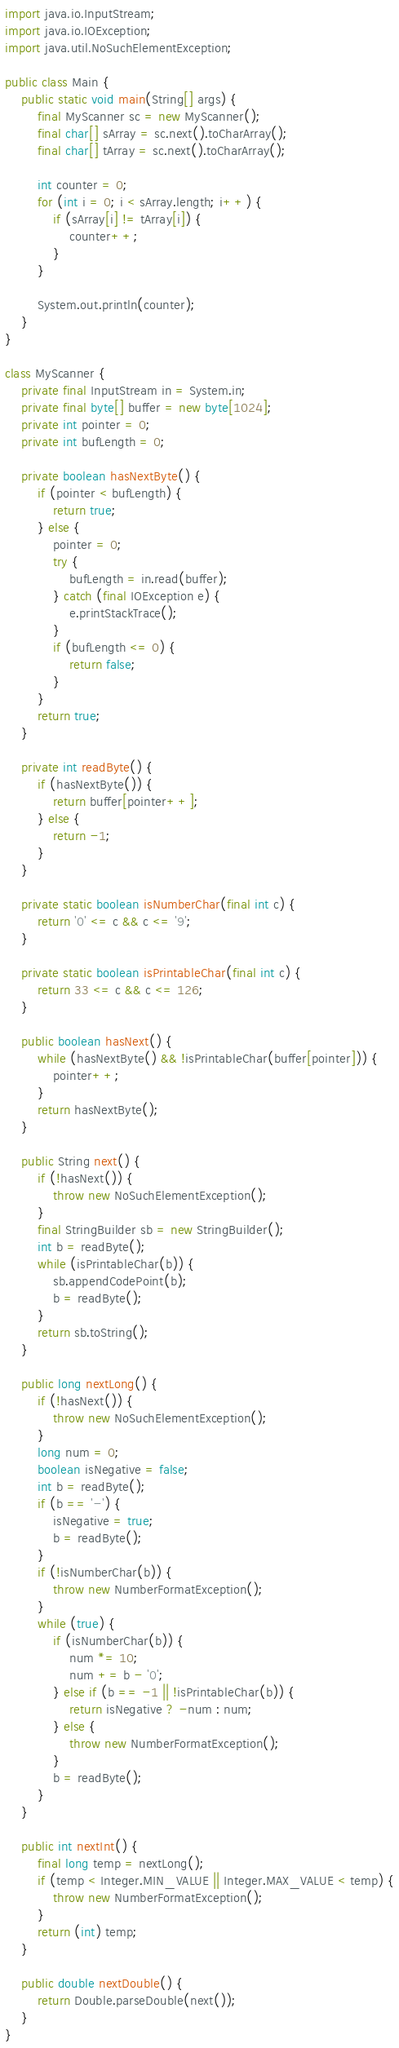Convert code to text. <code><loc_0><loc_0><loc_500><loc_500><_Java_>import java.io.InputStream;
import java.io.IOException;
import java.util.NoSuchElementException;

public class Main {
    public static void main(String[] args) {
        final MyScanner sc = new MyScanner();
        final char[] sArray = sc.next().toCharArray();
        final char[] tArray = sc.next().toCharArray();

        int counter = 0;
        for (int i = 0; i < sArray.length; i++) {
            if (sArray[i] != tArray[i]) {
                counter++;
            }
        }

        System.out.println(counter);
    }
}

class MyScanner {
    private final InputStream in = System.in;
    private final byte[] buffer = new byte[1024];
    private int pointer = 0;
    private int bufLength = 0;

    private boolean hasNextByte() {
        if (pointer < bufLength) {
            return true;
        } else {
            pointer = 0;
            try {
                bufLength = in.read(buffer);
            } catch (final IOException e) {
                e.printStackTrace();
            }
            if (bufLength <= 0) {
                return false;
            }
        }
        return true;
    }

    private int readByte() {
        if (hasNextByte()) {
            return buffer[pointer++];
        } else {
            return -1;
        }
    }

    private static boolean isNumberChar(final int c) {
        return '0' <= c && c <= '9';
    }

    private static boolean isPrintableChar(final int c) {
        return 33 <= c && c <= 126;
    }

    public boolean hasNext() {
        while (hasNextByte() && !isPrintableChar(buffer[pointer])) {
            pointer++;
        }
        return hasNextByte();
    }

    public String next() {
        if (!hasNext()) {
            throw new NoSuchElementException();
        }
        final StringBuilder sb = new StringBuilder();
        int b = readByte();
        while (isPrintableChar(b)) {
            sb.appendCodePoint(b);
            b = readByte();
        }
        return sb.toString();
    }

    public long nextLong() {
        if (!hasNext()) {
            throw new NoSuchElementException();
        }
        long num = 0;
        boolean isNegative = false;
        int b = readByte();
        if (b == '-') {
            isNegative = true;
            b = readByte();
        }
        if (!isNumberChar(b)) {
            throw new NumberFormatException();
        }
        while (true) {
            if (isNumberChar(b)) {
                num *= 10;
                num += b - '0';
            } else if (b == -1 || !isPrintableChar(b)) {
                return isNegative ? -num : num;
            } else {
                throw new NumberFormatException();
            }
            b = readByte();
        }
    }

    public int nextInt() {
        final long temp = nextLong();
        if (temp < Integer.MIN_VALUE || Integer.MAX_VALUE < temp) {
            throw new NumberFormatException();
        }
        return (int) temp;
    }

    public double nextDouble() {
        return Double.parseDouble(next());
    }
}
</code> 